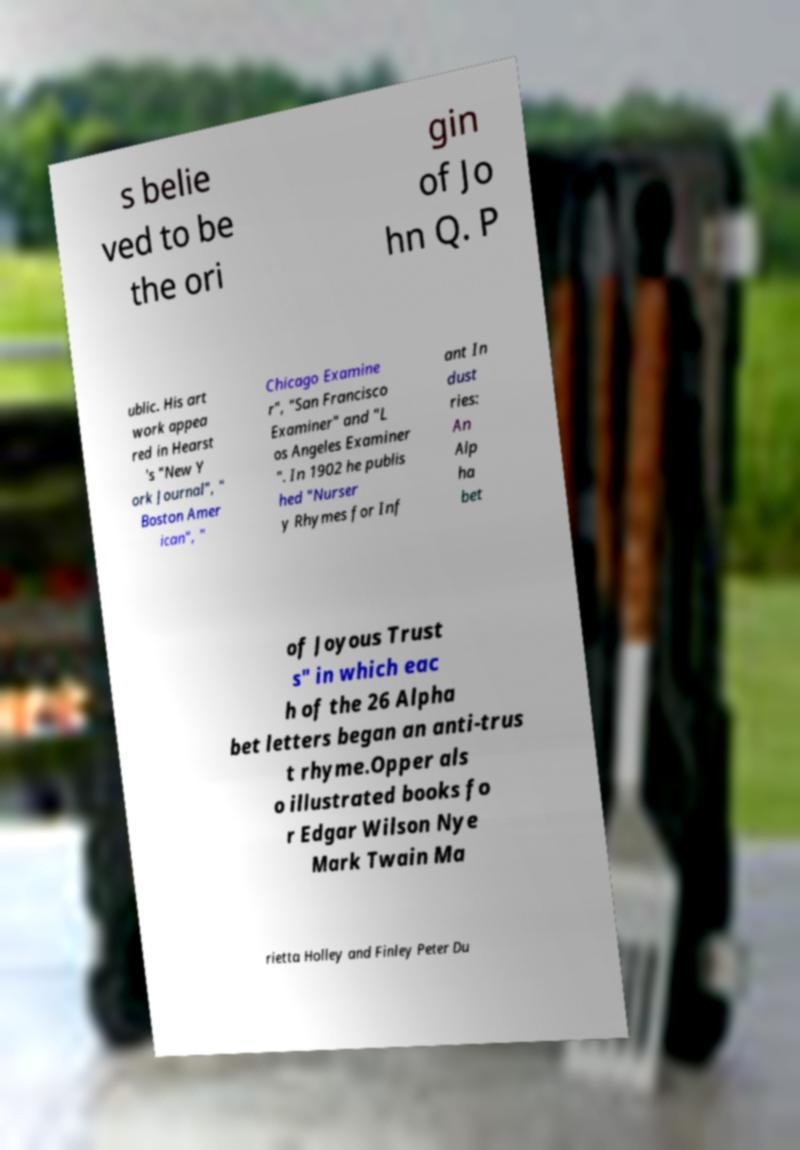Could you assist in decoding the text presented in this image and type it out clearly? s belie ved to be the ori gin of Jo hn Q. P ublic. His art work appea red in Hearst 's "New Y ork Journal", " Boston Amer ican", " Chicago Examine r", "San Francisco Examiner" and "L os Angeles Examiner ". In 1902 he publis hed "Nurser y Rhymes for Inf ant In dust ries: An Alp ha bet of Joyous Trust s" in which eac h of the 26 Alpha bet letters began an anti-trus t rhyme.Opper als o illustrated books fo r Edgar Wilson Nye Mark Twain Ma rietta Holley and Finley Peter Du 